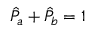<formula> <loc_0><loc_0><loc_500><loc_500>\hat { P } _ { a } + \hat { P } _ { b } = 1</formula> 